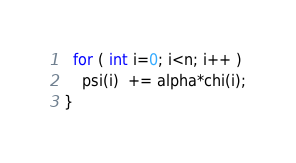<code> <loc_0><loc_0><loc_500><loc_500><_C_>  for ( int i=0; i<n; i++ )
    psi(i)  += alpha*chi(i);
}
</code> 